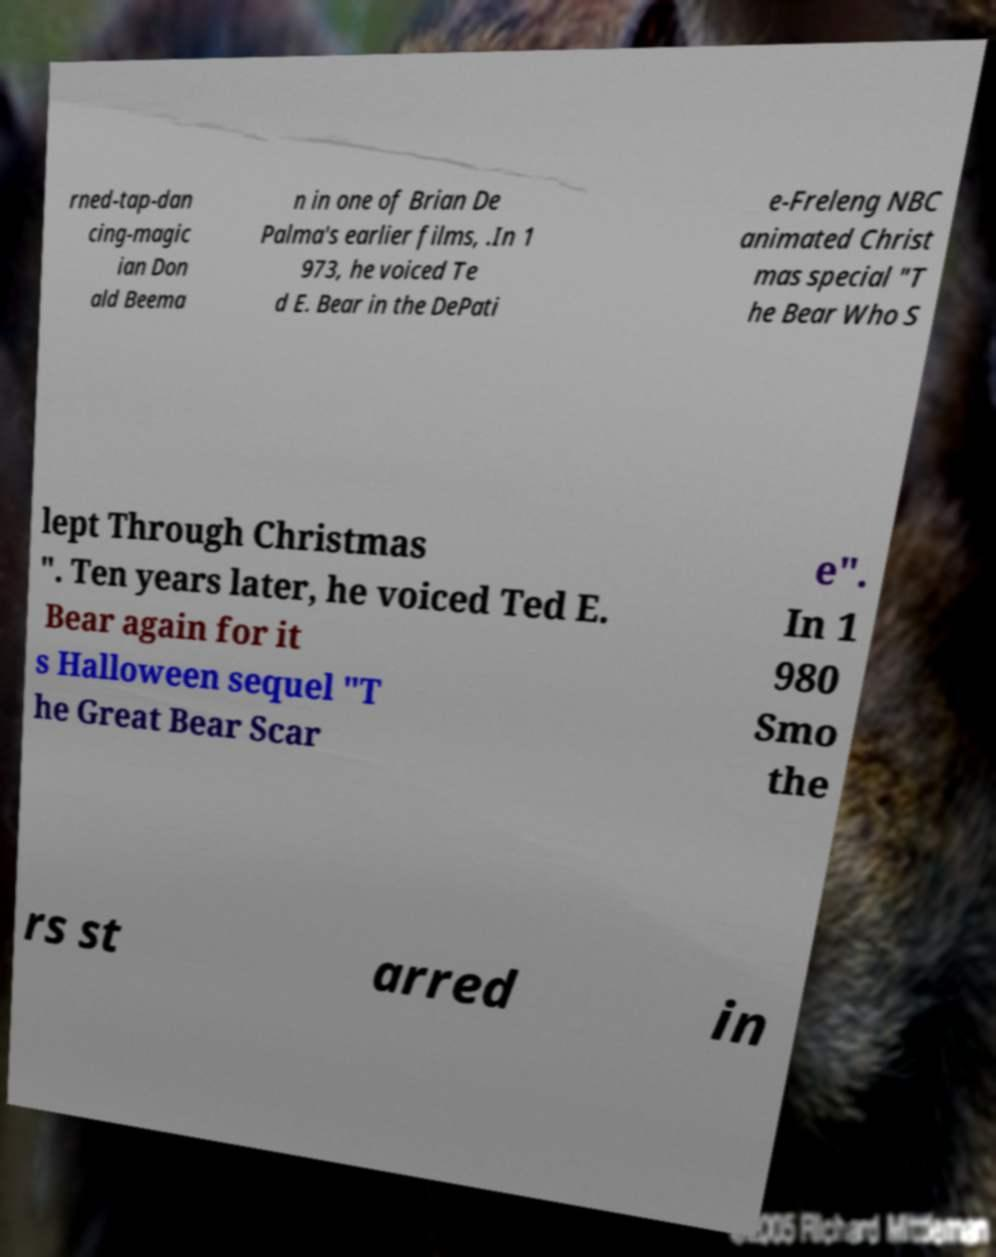Can you accurately transcribe the text from the provided image for me? rned-tap-dan cing-magic ian Don ald Beema n in one of Brian De Palma's earlier films, .In 1 973, he voiced Te d E. Bear in the DePati e-Freleng NBC animated Christ mas special "T he Bear Who S lept Through Christmas ". Ten years later, he voiced Ted E. Bear again for it s Halloween sequel "T he Great Bear Scar e". In 1 980 Smo the rs st arred in 